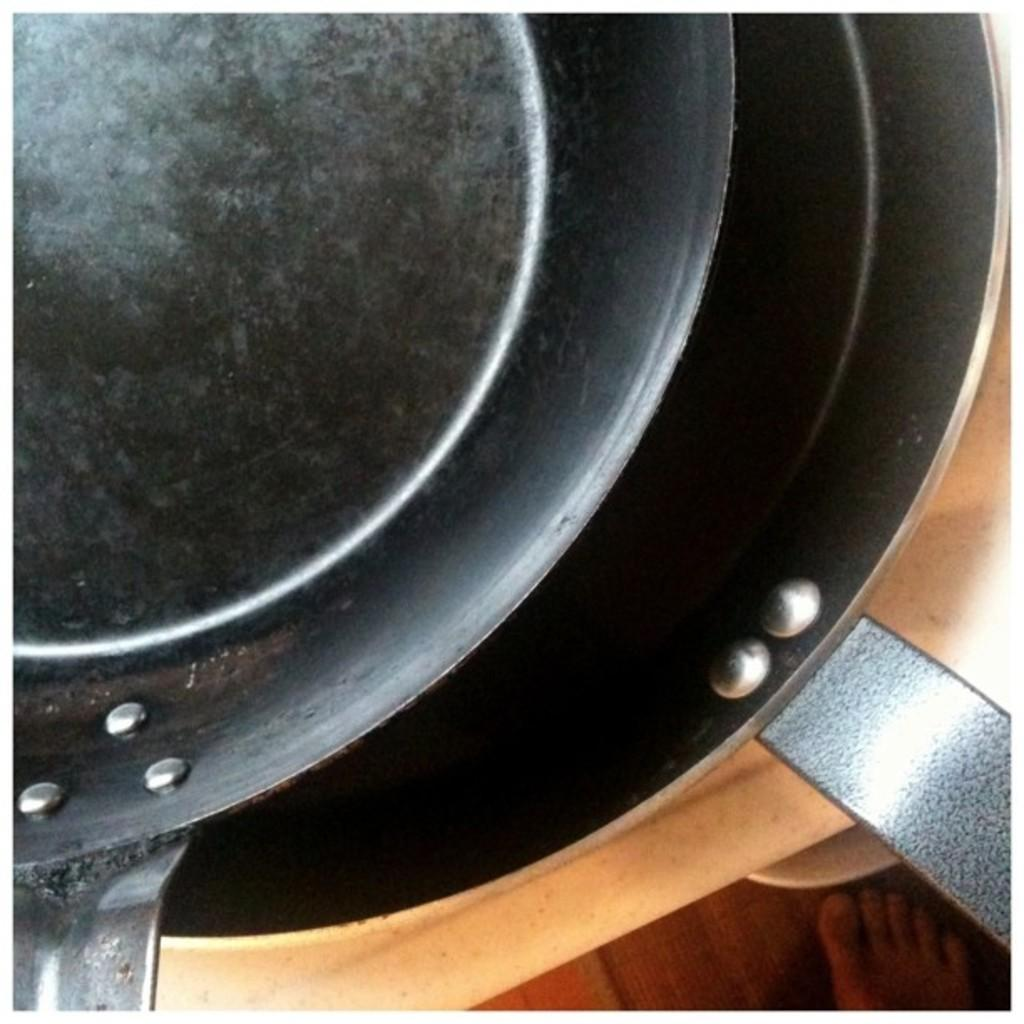What objects are on the platform in the image? There are pans on a platform in the image. Can you describe anything related to a person in the image? The foot of a person is visible on the floor in the image. What type of ball is being used by the person in the image? There is no ball present in the image; only pans on a platform and a foot on the floor are visible. 